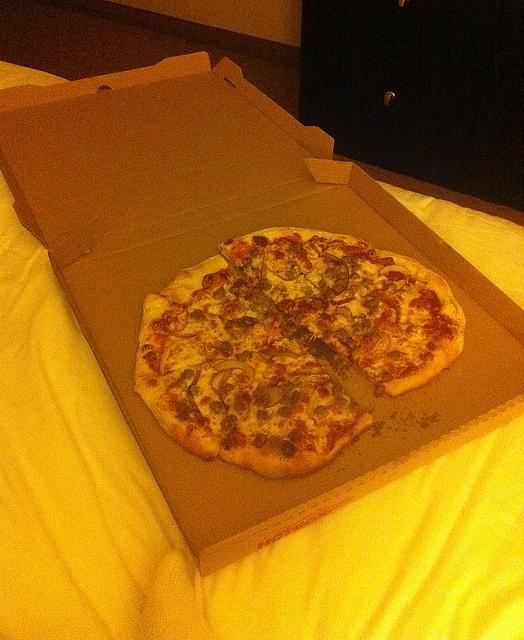Is this a bachelor's pizza?
Quick response, please. Yes. What color is the sock?
Keep it brief. Yellow. What type of box is holding the pizza?
Keep it brief. Cardboard. 